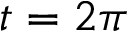Convert formula to latex. <formula><loc_0><loc_0><loc_500><loc_500>t = 2 \pi</formula> 